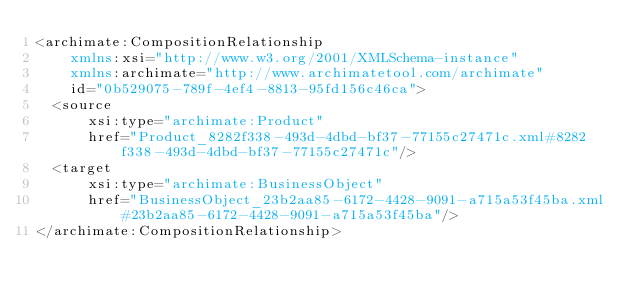<code> <loc_0><loc_0><loc_500><loc_500><_XML_><archimate:CompositionRelationship
    xmlns:xsi="http://www.w3.org/2001/XMLSchema-instance"
    xmlns:archimate="http://www.archimatetool.com/archimate"
    id="0b529075-789f-4ef4-8813-95fd156c46ca">
  <source
      xsi:type="archimate:Product"
      href="Product_8282f338-493d-4dbd-bf37-77155c27471c.xml#8282f338-493d-4dbd-bf37-77155c27471c"/>
  <target
      xsi:type="archimate:BusinessObject"
      href="BusinessObject_23b2aa85-6172-4428-9091-a715a53f45ba.xml#23b2aa85-6172-4428-9091-a715a53f45ba"/>
</archimate:CompositionRelationship>
</code> 